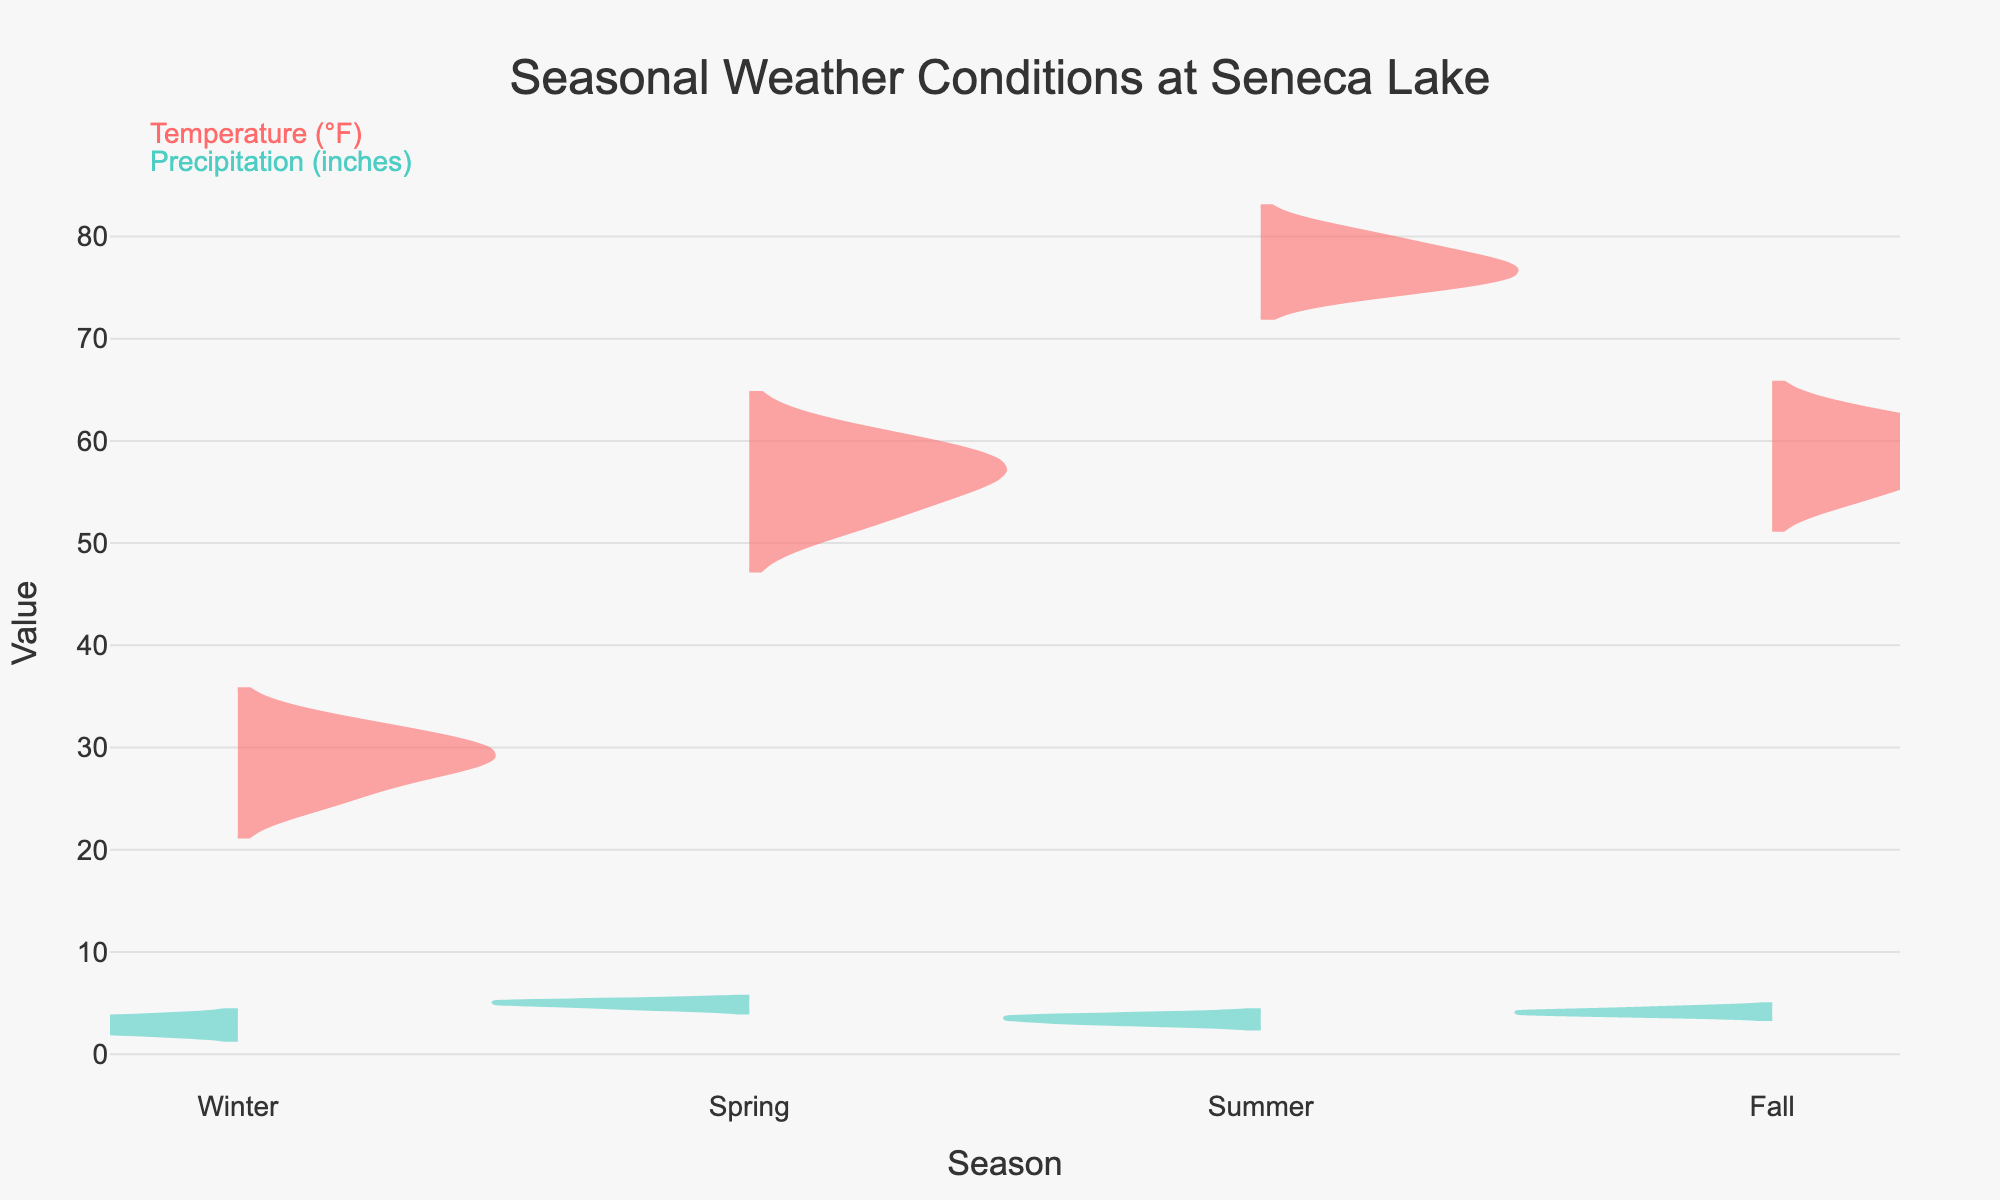What's the title of the figure? The title is displayed at the top center of the figure and reads 'Seasonal Weather Conditions at Seneca Lake'.
Answer: Seasonal Weather Conditions at Seneca Lake Which color represents Temperature? The color representing Temperature is visible in the legend annotations, and it is a shade of red.
Answer: Red How many seasons are compared in this figure? There are four different seasons labeled on the x-axis: Winter, Spring, Summer, and Fall.
Answer: Four What is the median Winter Temperature? The median value is indicated by the middle line in the box plot overlay within the Winter temperature violin plot. The median Winter temperature is 29°F.
Answer: 29°F What's the range of Spring Precipitation values? The range can be observed by looking at the upper and lower bounds of the violin plot for Spring Precipitation. The values range from 4.5 to 5.2 inches.
Answer: 4.5 to 5.2 inches Which season has the highest median Temperature? By comparing the median lines in the violin plots for Temperature across all seasons, the median line in the Summer temperature plot is highest.
Answer: Summer During which season does Precipitation show the widest spread? The spread can be assessed by looking at the width of the violin plots. The Spring Precipitation violin plot spans the widest range of values.
Answer: Spring Compare the median Summer Temperature and Fall Temperature. Which one is higher, and by how much? The median lines in the box plots show that the median Summer temperature is higher than the median Fall temperature. Summer median is 77°F, and Fall median is 59°F. So, 77°F - 59°F = 18°F.
Answer: Summer, by 18°F What's the interquartile range (IQR) for Winter Temperature? The IQR is calculated by subtracting the 25th percentile value from the 75th percentile value in the box plot for Winter Temperature. The 75th percentile is 31.5°F, and the 25th percentile is 27.5°F. So, 31.5°F - 27.5°F = 4°F.
Answer: 4°F Are there any seasons where Temperature and Precipitation distributions don't overlap? Yes, the violin plots indicate that the Temperature and Precipitation distributions for all seasons are distinct and do not overlap on the y-axis.
Answer: Yes 